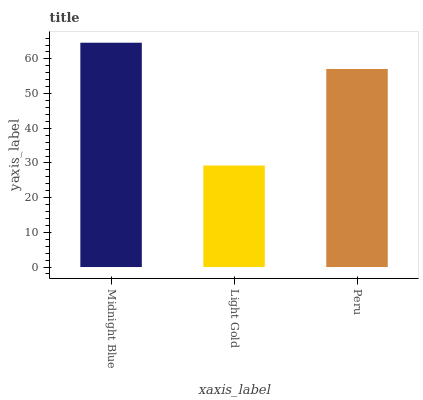Is Light Gold the minimum?
Answer yes or no. Yes. Is Midnight Blue the maximum?
Answer yes or no. Yes. Is Peru the minimum?
Answer yes or no. No. Is Peru the maximum?
Answer yes or no. No. Is Peru greater than Light Gold?
Answer yes or no. Yes. Is Light Gold less than Peru?
Answer yes or no. Yes. Is Light Gold greater than Peru?
Answer yes or no. No. Is Peru less than Light Gold?
Answer yes or no. No. Is Peru the high median?
Answer yes or no. Yes. Is Peru the low median?
Answer yes or no. Yes. Is Midnight Blue the high median?
Answer yes or no. No. Is Midnight Blue the low median?
Answer yes or no. No. 